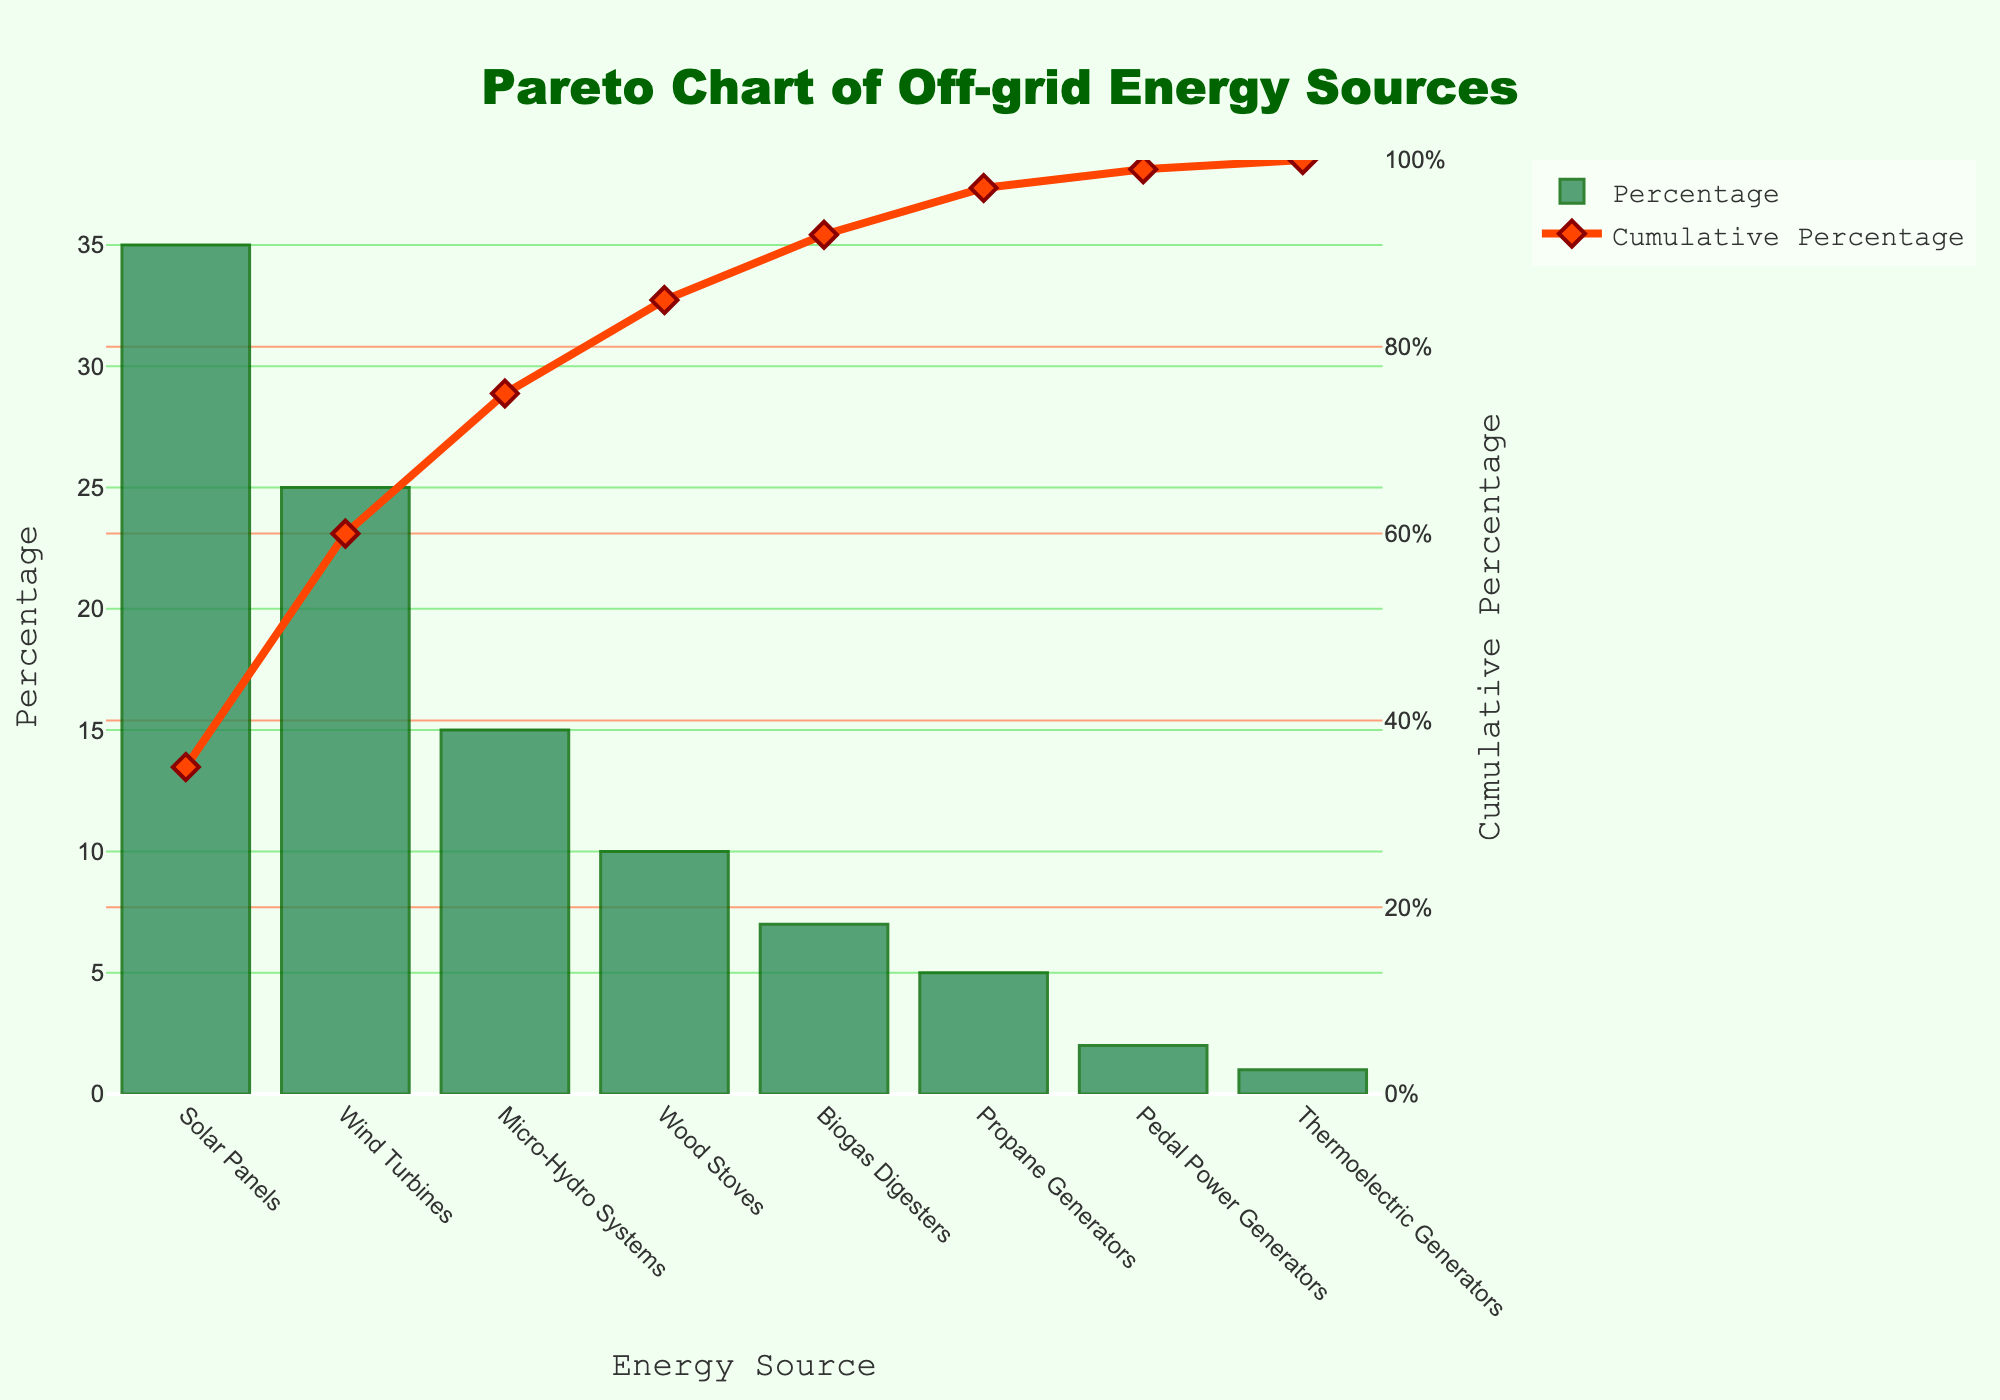What is the most popular off-grid energy source among homesteaders? The highest bar represents the most popular energy source, which is Solar Panels with a percentage of 35%.
Answer: Solar Panels What is the cumulative percentage after including Wind Turbines? Add the percentages of Solar Panels (35%) and Wind Turbines (25%). The cumulative percentage is 35% + 25% = 60%.
Answer: 60% Which energy sources, when combined, make up more than 50% of the total? The cumulative percentages for the top three energy sources - Solar Panels (35%) and Wind Turbines (25%) - sum up to 60%. Since 60% is more than 50%, these two sources are sufficient.
Answer: Solar Panels and Wind Turbines What percentage of homesteaders use Biogas Digesters alone? Look at the bar representing Biogas Digesters, which shows a percentage of 7%.
Answer: 7% By how much does the percentage of homesteaders using Wood Stoves exceed that of those using Propane Generators? Subtract the percentage of Propane Generators (5%) from that of Wood Stoves (10%). This gives 10% - 5% = 5%.
Answer: 5% Which energy source is the least popular? The smallest bar identifies the least popular energy source, which is Thermoelectric Generators with a percentage of 1%.
Answer: Thermoelectric Generators What is the cumulative percentage after including all energy sources? The cumulative percentage for all sources combined should be 100%.
Answer: 100% How many energy sources contribute to the first 75% of total usage? Adding the cumulative percentages, we see 35% (Solar Panels) + 25% (Wind Turbines) = 60%, and then adding another 15% (Micro-Hydro Systems) reaches 75%.
Answer: 3 What percentage of usage do Pedal Power Generators represent relative to Solar Panels? Divide the percentage of Pedal Power Generators (2%) by that of Solar Panels (35%), then multiply by 100. (2%/35%) * 100 ≈ 5.7%.
Answer: 5.7% What is the combined percentage of homesteaders using either Micro-Hydro Systems or Wood Stoves? Add the percentage of Micro-Hydro Systems (15%) and Wood Stoves (10%). This results in 15% + 10% = 25%.
Answer: 25% 